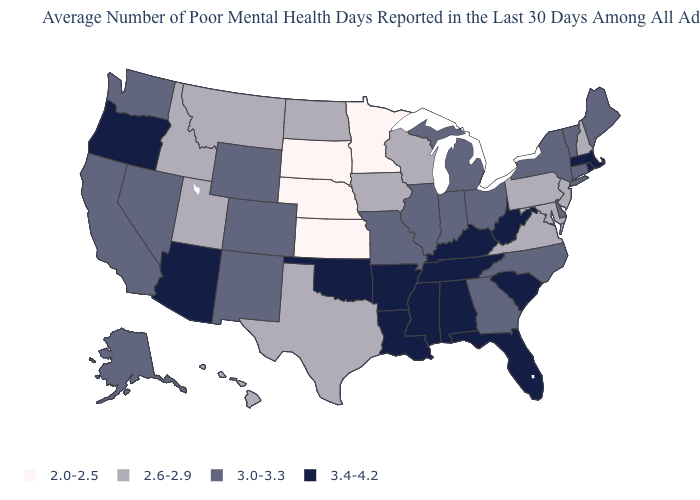What is the lowest value in the South?
Write a very short answer. 2.6-2.9. Name the states that have a value in the range 2.0-2.5?
Keep it brief. Kansas, Minnesota, Nebraska, South Dakota. What is the highest value in the USA?
Answer briefly. 3.4-4.2. How many symbols are there in the legend?
Quick response, please. 4. Which states have the lowest value in the Northeast?
Concise answer only. New Hampshire, New Jersey, Pennsylvania. Name the states that have a value in the range 2.0-2.5?
Keep it brief. Kansas, Minnesota, Nebraska, South Dakota. Does the map have missing data?
Concise answer only. No. Does Texas have the lowest value in the South?
Answer briefly. Yes. What is the lowest value in the MidWest?
Keep it brief. 2.0-2.5. What is the value of Maine?
Quick response, please. 3.0-3.3. Among the states that border Florida , does Georgia have the highest value?
Short answer required. No. Which states have the lowest value in the USA?
Give a very brief answer. Kansas, Minnesota, Nebraska, South Dakota. Among the states that border Montana , which have the lowest value?
Quick response, please. South Dakota. What is the highest value in the MidWest ?
Be succinct. 3.0-3.3. Does Kansas have the lowest value in the USA?
Concise answer only. Yes. 